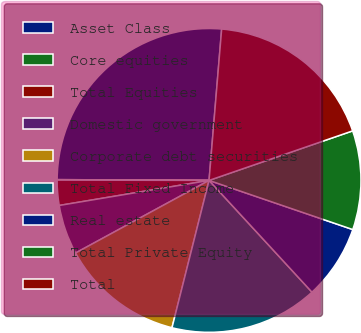<chart> <loc_0><loc_0><loc_500><loc_500><pie_chart><fcel>Asset Class<fcel>Core equities<fcel>Total Equities<fcel>Domestic government<fcel>Corporate debt securities<fcel>Total Fixed Income<fcel>Real estate<fcel>Total Private Equity<fcel>Total<nl><fcel>26.24%<fcel>0.05%<fcel>2.67%<fcel>5.29%<fcel>13.15%<fcel>15.77%<fcel>7.91%<fcel>10.53%<fcel>18.39%<nl></chart> 